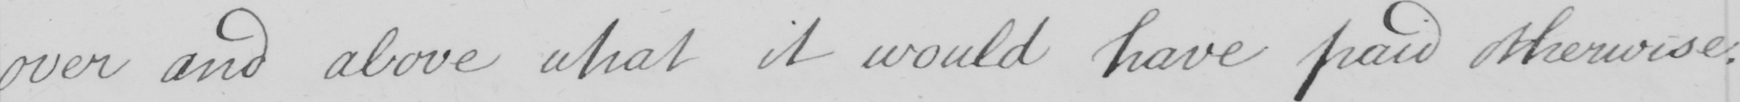Please provide the text content of this handwritten line. over and above what it would have paid otherwise : 